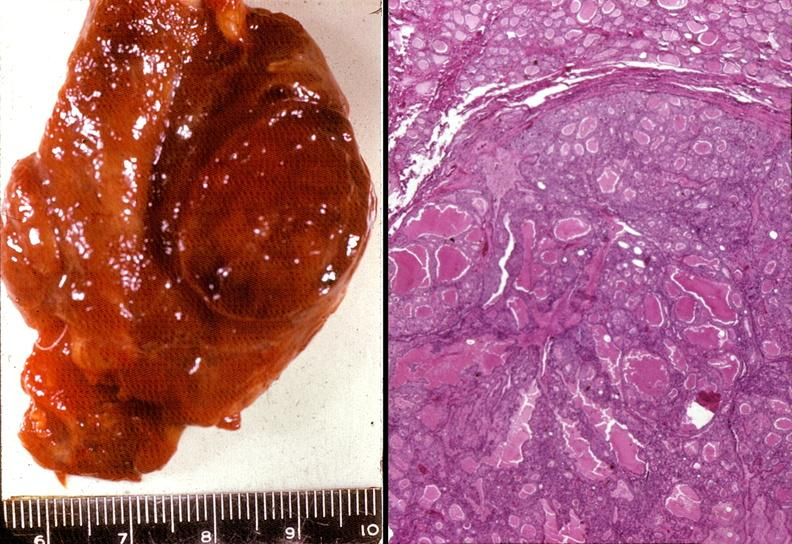where does this belong to?
Answer the question using a single word or phrase. Endocrine system 